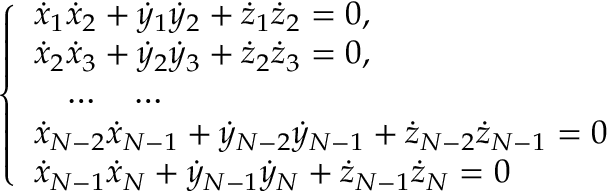<formula> <loc_0><loc_0><loc_500><loc_500>\left \{ \begin{array} { l } { { \dot { x } } _ { 1 } { \dot { x } } _ { 2 } + { \dot { y } } _ { 1 } { \dot { y } } _ { 2 } + { \dot { z } } _ { 1 } { \dot { z } } _ { 2 } = 0 , } \\ { { \dot { x } } _ { 2 } { \dot { x } } _ { 3 } + { \dot { y } } _ { 2 } { \dot { y } } _ { 3 } + { \dot { z } } _ { 2 } { \dot { z } } _ { 3 } = 0 , } \\ { \quad \dots \quad \dots } \\ { { \dot { x } } _ { N - 2 } { \dot { x } } _ { N - 1 } + { \dot { y } } _ { N - 2 } { \dot { y } } _ { N - 1 } + { \dot { z } } _ { N - 2 } { \dot { z } } _ { N - 1 } = 0 } \\ { { \dot { x } } _ { N - 1 } { \dot { x } } _ { N } + { \dot { y } } _ { N - 1 } { \dot { y } } _ { N } + { \dot { z } } _ { N - 1 } { \dot { z } } _ { N } = 0 } \end{array}</formula> 